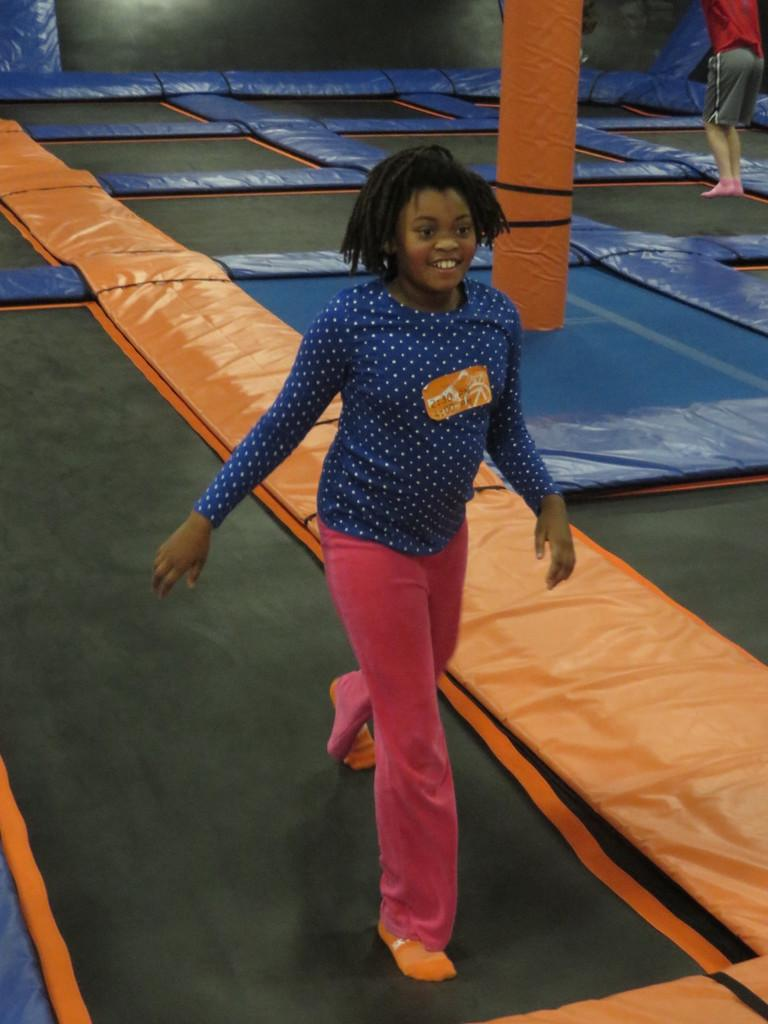Who is the main subject in the image? There is a girl in the image. What is the girl doing in the image? The girl is walking on a panel mat. Are there any other people in the image? Yes, there is a boy in the background of the image. What is the boy doing in the image? The boy is standing on the mat. What type of pickle is the girl holding in the image? There is no pickle present in the image. 